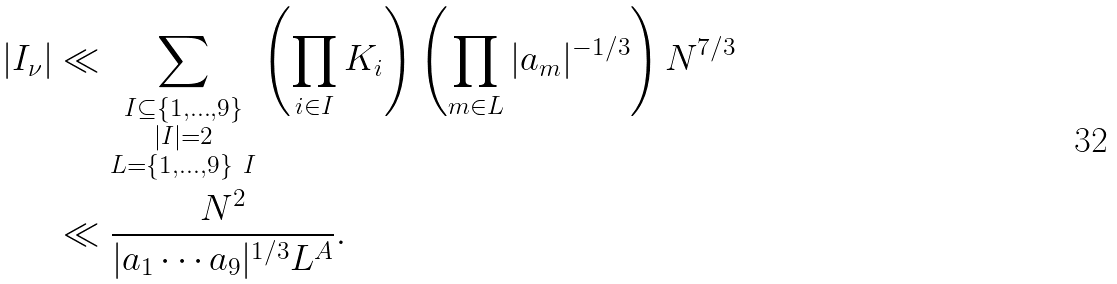<formula> <loc_0><loc_0><loc_500><loc_500>| I _ { \nu } | & \ll \sum _ { \substack { I \subseteq \{ 1 , \dots , 9 \} \\ | I | = 2 \\ L = \{ 1 , \dots , 9 \} \ I } } \left ( \prod _ { i \in I } K _ { i } \right ) \left ( \prod _ { m \in L } | a _ { m } | ^ { - 1 / 3 } \right ) N ^ { 7 / 3 } \\ & \ll \frac { N ^ { 2 } } { | a _ { 1 } \cdots a _ { 9 } | ^ { 1 / 3 } L ^ { A } } .</formula> 